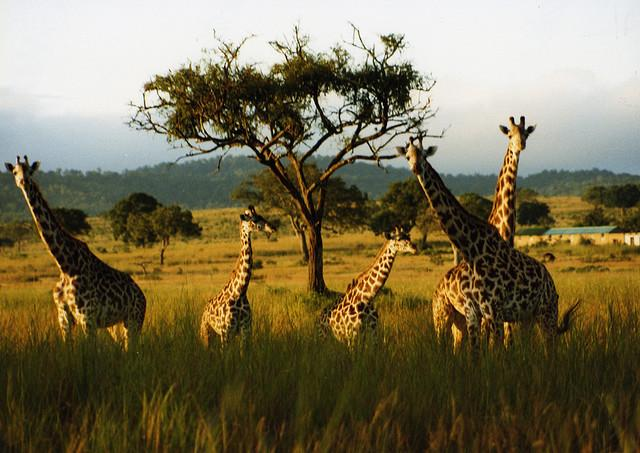How heavy is a newborn giraffe calf in general? Please explain your reasoning. 100 kg. Depends on their size. 